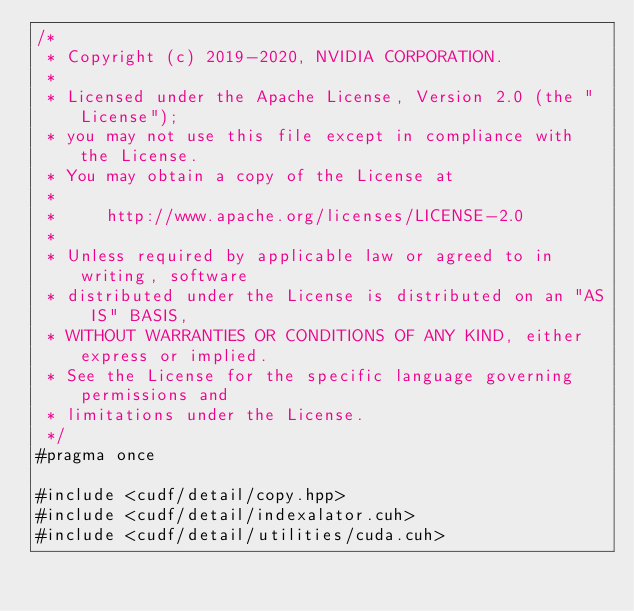<code> <loc_0><loc_0><loc_500><loc_500><_Cuda_>/*
 * Copyright (c) 2019-2020, NVIDIA CORPORATION.
 *
 * Licensed under the Apache License, Version 2.0 (the "License");
 * you may not use this file except in compliance with the License.
 * You may obtain a copy of the License at
 *
 *     http://www.apache.org/licenses/LICENSE-2.0
 *
 * Unless required by applicable law or agreed to in writing, software
 * distributed under the License is distributed on an "AS IS" BASIS,
 * WITHOUT WARRANTIES OR CONDITIONS OF ANY KIND, either express or implied.
 * See the License for the specific language governing permissions and
 * limitations under the License.
 */
#pragma once

#include <cudf/detail/copy.hpp>
#include <cudf/detail/indexalator.cuh>
#include <cudf/detail/utilities/cuda.cuh></code> 